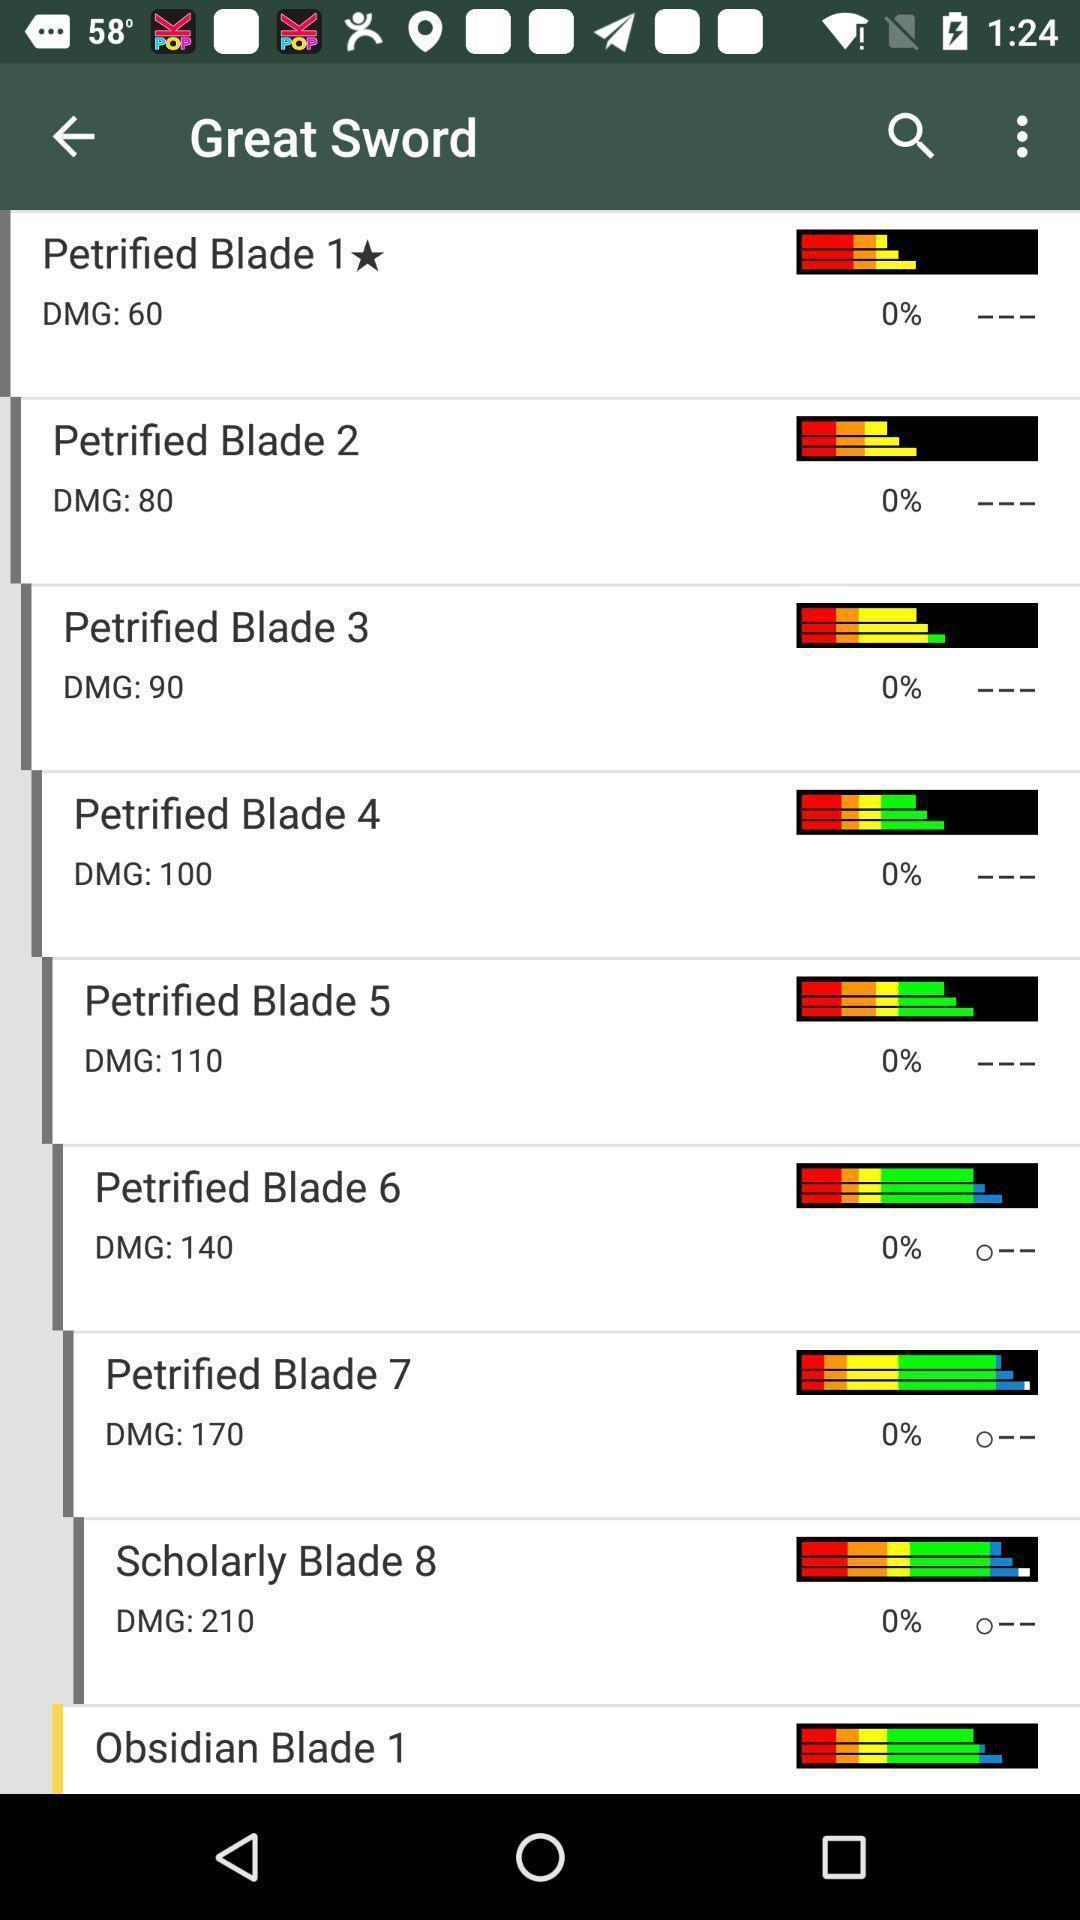What can you discern from this picture? Page displaying various blades options with more option. 